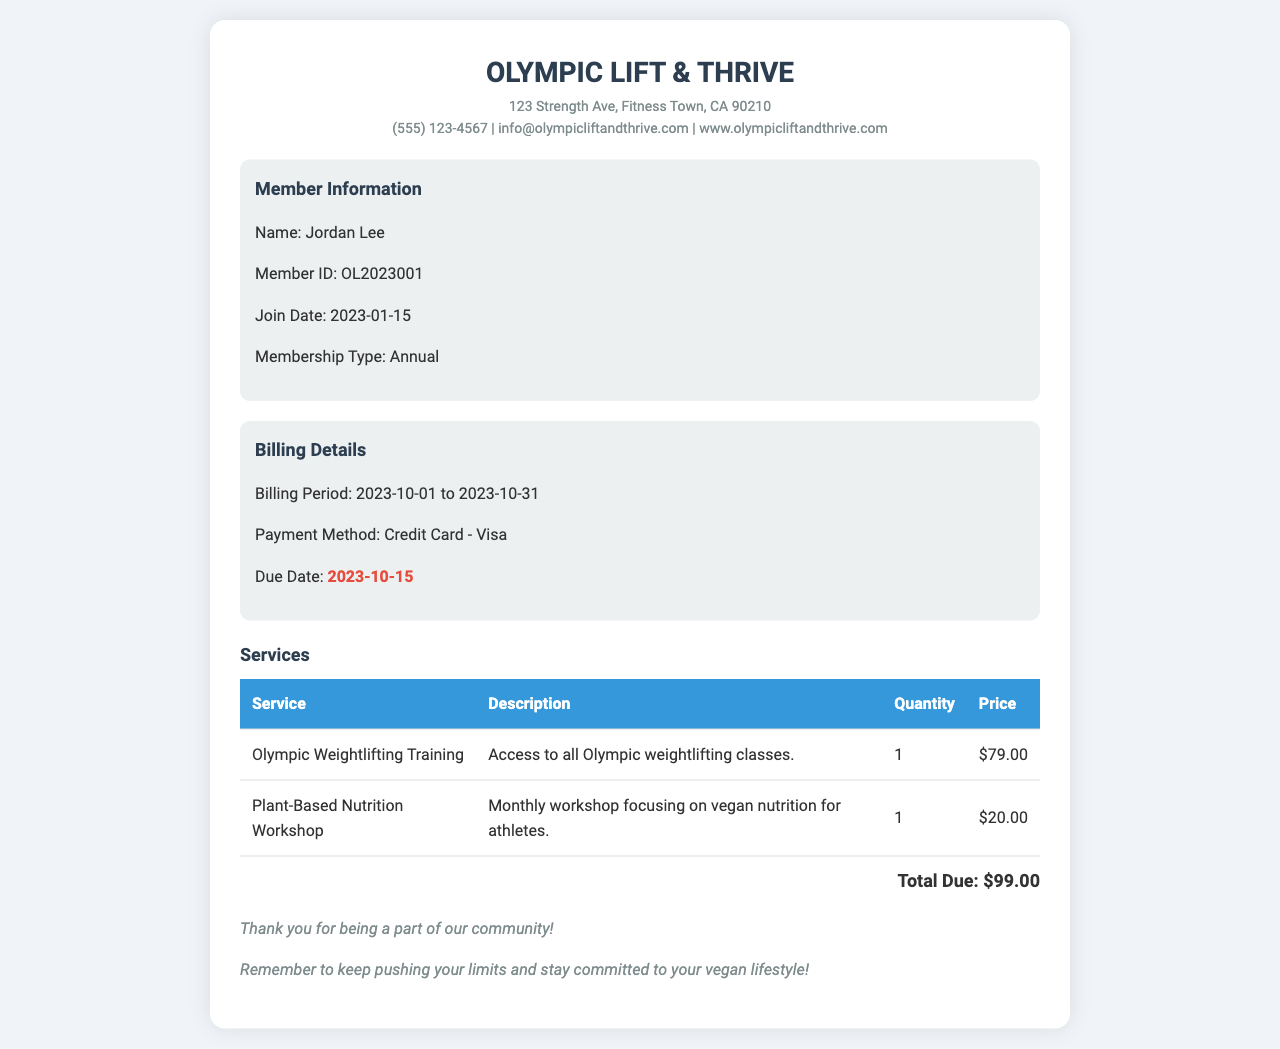What is the member's name? The member's name is stated in the member information section of the document.
Answer: Jordan Lee What is the member ID? The member ID is a unique identifier found in the member information section.
Answer: OL2023001 When is the due date for payment? The due date is highlighted in the billing details section of the document.
Answer: 2023-10-15 What services are included in the billing statement? The services are listed in a table format with their descriptions and pricing.
Answer: Olympic Weightlifting Training, Plant-Based Nutrition Workshop What is the total amount due? The total due is shown at the end of the services section.
Answer: $99.00 What payment method is used? The payment method is mentioned in the billing details section.
Answer: Credit Card - Visa What is the join date of the member? The join date is specified in the member information section.
Answer: 2023-01-15 How much does the Plant-Based Nutrition Workshop cost? The cost is noted in the table under the price column for that service.
Answer: $20.00 Why should the member stay committed to their vegan lifestyle? The reason is mentioned in the notes section as encouragement.
Answer: Stay committed to your vegan lifestyle! 